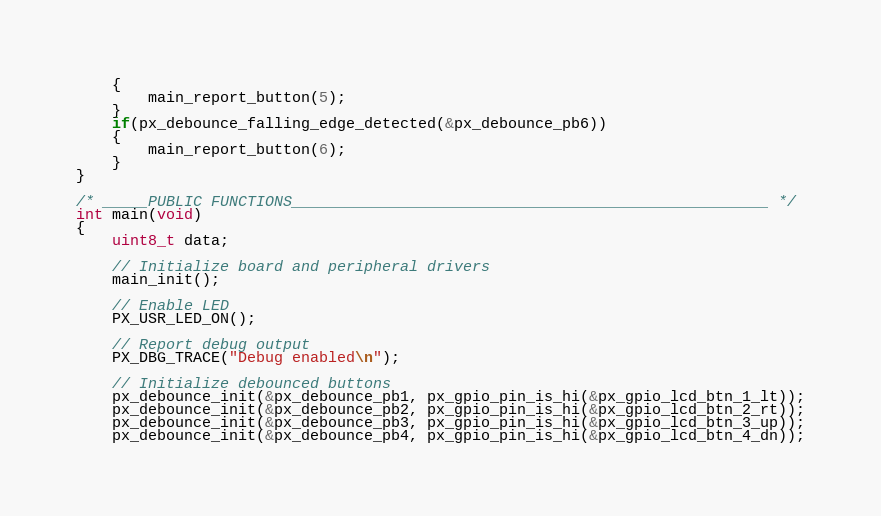<code> <loc_0><loc_0><loc_500><loc_500><_C_>    {
        main_report_button(5);
    }
    if(px_debounce_falling_edge_detected(&px_debounce_pb6))
    {
        main_report_button(6);
    }
}

/* _____PUBLIC FUNCTIONS_____________________________________________________ */
int main(void)
{
    uint8_t data;

    // Initialize board and peripheral drivers
    main_init();

    // Enable LED
    PX_USR_LED_ON();

    // Report debug output
    PX_DBG_TRACE("Debug enabled\n");

    // Initialize debounced buttons
    px_debounce_init(&px_debounce_pb1, px_gpio_pin_is_hi(&px_gpio_lcd_btn_1_lt));
    px_debounce_init(&px_debounce_pb2, px_gpio_pin_is_hi(&px_gpio_lcd_btn_2_rt));
    px_debounce_init(&px_debounce_pb3, px_gpio_pin_is_hi(&px_gpio_lcd_btn_3_up));
    px_debounce_init(&px_debounce_pb4, px_gpio_pin_is_hi(&px_gpio_lcd_btn_4_dn));</code> 